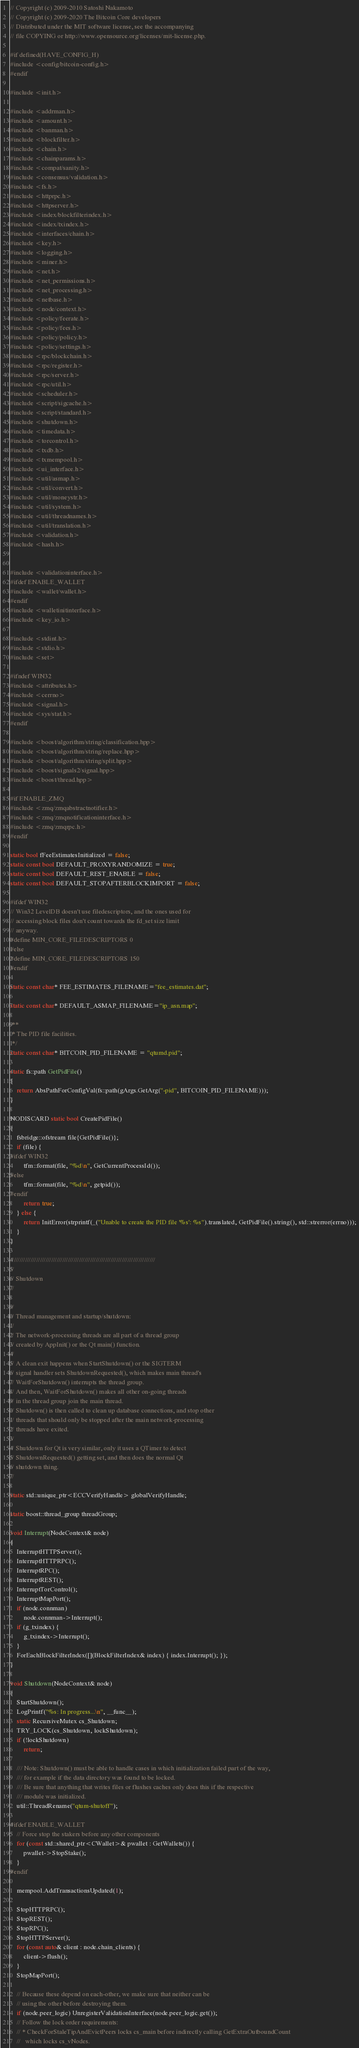<code> <loc_0><loc_0><loc_500><loc_500><_C++_>// Copyright (c) 2009-2010 Satoshi Nakamoto
// Copyright (c) 2009-2020 The Bitcoin Core developers
// Distributed under the MIT software license, see the accompanying
// file COPYING or http://www.opensource.org/licenses/mit-license.php.

#if defined(HAVE_CONFIG_H)
#include <config/bitcoin-config.h>
#endif

#include <init.h>

#include <addrman.h>
#include <amount.h>
#include <banman.h>
#include <blockfilter.h>
#include <chain.h>
#include <chainparams.h>
#include <compat/sanity.h>
#include <consensus/validation.h>
#include <fs.h>
#include <httprpc.h>
#include <httpserver.h>
#include <index/blockfilterindex.h>
#include <index/txindex.h>
#include <interfaces/chain.h>
#include <key.h>
#include <logging.h>
#include <miner.h>
#include <net.h>
#include <net_permissions.h>
#include <net_processing.h>
#include <netbase.h>
#include <node/context.h>
#include <policy/feerate.h>
#include <policy/fees.h>
#include <policy/policy.h>
#include <policy/settings.h>
#include <rpc/blockchain.h>
#include <rpc/register.h>
#include <rpc/server.h>
#include <rpc/util.h>
#include <scheduler.h>
#include <script/sigcache.h>
#include <script/standard.h>
#include <shutdown.h>
#include <timedata.h>
#include <torcontrol.h>
#include <txdb.h>
#include <txmempool.h>
#include <ui_interface.h>
#include <util/asmap.h>
#include <util/convert.h>
#include <util/moneystr.h>
#include <util/system.h>
#include <util/threadnames.h>
#include <util/translation.h>
#include <validation.h>
#include <hash.h>


#include <validationinterface.h>
#ifdef ENABLE_WALLET
#include <wallet/wallet.h>
#endif
#include <walletinitinterface.h>
#include <key_io.h>

#include <stdint.h>
#include <stdio.h>
#include <set>

#ifndef WIN32
#include <attributes.h>
#include <cerrno>
#include <signal.h>
#include <sys/stat.h>
#endif

#include <boost/algorithm/string/classification.hpp>
#include <boost/algorithm/string/replace.hpp>
#include <boost/algorithm/string/split.hpp>
#include <boost/signals2/signal.hpp>
#include <boost/thread.hpp>

#if ENABLE_ZMQ
#include <zmq/zmqabstractnotifier.h>
#include <zmq/zmqnotificationinterface.h>
#include <zmq/zmqrpc.h>
#endif

static bool fFeeEstimatesInitialized = false;
static const bool DEFAULT_PROXYRANDOMIZE = true;
static const bool DEFAULT_REST_ENABLE = false;
static const bool DEFAULT_STOPAFTERBLOCKIMPORT = false;

#ifdef WIN32
// Win32 LevelDB doesn't use filedescriptors, and the ones used for
// accessing block files don't count towards the fd_set size limit
// anyway.
#define MIN_CORE_FILEDESCRIPTORS 0
#else
#define MIN_CORE_FILEDESCRIPTORS 150
#endif

static const char* FEE_ESTIMATES_FILENAME="fee_estimates.dat";

static const char* DEFAULT_ASMAP_FILENAME="ip_asn.map";

/**
 * The PID file facilities.
 */
static const char* BITCOIN_PID_FILENAME = "qtumd.pid";

static fs::path GetPidFile()
{
    return AbsPathForConfigVal(fs::path(gArgs.GetArg("-pid", BITCOIN_PID_FILENAME)));
}

NODISCARD static bool CreatePidFile()
{
    fsbridge::ofstream file{GetPidFile()};
    if (file) {
#ifdef WIN32
        tfm::format(file, "%d\n", GetCurrentProcessId());
#else
        tfm::format(file, "%d\n", getpid());
#endif
        return true;
    } else {
        return InitError(strprintf(_("Unable to create the PID file '%s': %s").translated, GetPidFile().string(), std::strerror(errno)));
    }
}

//////////////////////////////////////////////////////////////////////////////
//
// Shutdown
//

//
// Thread management and startup/shutdown:
//
// The network-processing threads are all part of a thread group
// created by AppInit() or the Qt main() function.
//
// A clean exit happens when StartShutdown() or the SIGTERM
// signal handler sets ShutdownRequested(), which makes main thread's
// WaitForShutdown() interrupts the thread group.
// And then, WaitForShutdown() makes all other on-going threads
// in the thread group join the main thread.
// Shutdown() is then called to clean up database connections, and stop other
// threads that should only be stopped after the main network-processing
// threads have exited.
//
// Shutdown for Qt is very similar, only it uses a QTimer to detect
// ShutdownRequested() getting set, and then does the normal Qt
// shutdown thing.
//

static std::unique_ptr<ECCVerifyHandle> globalVerifyHandle;

static boost::thread_group threadGroup;

void Interrupt(NodeContext& node)
{
    InterruptHTTPServer();
    InterruptHTTPRPC();
    InterruptRPC();
    InterruptREST();
    InterruptTorControl();
    InterruptMapPort();
    if (node.connman)
        node.connman->Interrupt();
    if (g_txindex) {
        g_txindex->Interrupt();
    }
    ForEachBlockFilterIndex([](BlockFilterIndex& index) { index.Interrupt(); });
}

void Shutdown(NodeContext& node)
{
    StartShutdown();
    LogPrintf("%s: In progress...\n", __func__);
    static RecursiveMutex cs_Shutdown;
    TRY_LOCK(cs_Shutdown, lockShutdown);
    if (!lockShutdown)
        return;

    /// Note: Shutdown() must be able to handle cases in which initialization failed part of the way,
    /// for example if the data directory was found to be locked.
    /// Be sure that anything that writes files or flushes caches only does this if the respective
    /// module was initialized.
    util::ThreadRename("qtum-shutoff");

#ifdef ENABLE_WALLET
    // Force stop the stakers before any other components
    for (const std::shared_ptr<CWallet>& pwallet : GetWallets()) {
        pwallet->StopStake();
    }
#endif

    mempool.AddTransactionsUpdated(1);

    StopHTTPRPC();
    StopREST();
    StopRPC();
    StopHTTPServer();
    for (const auto& client : node.chain_clients) {
        client->flush();
    }
    StopMapPort();

    // Because these depend on each-other, we make sure that neither can be
    // using the other before destroying them.
    if (node.peer_logic) UnregisterValidationInterface(node.peer_logic.get());
    // Follow the lock order requirements:
    // * CheckForStaleTipAndEvictPeers locks cs_main before indirectly calling GetExtraOutboundCount
    //   which locks cs_vNodes.</code> 